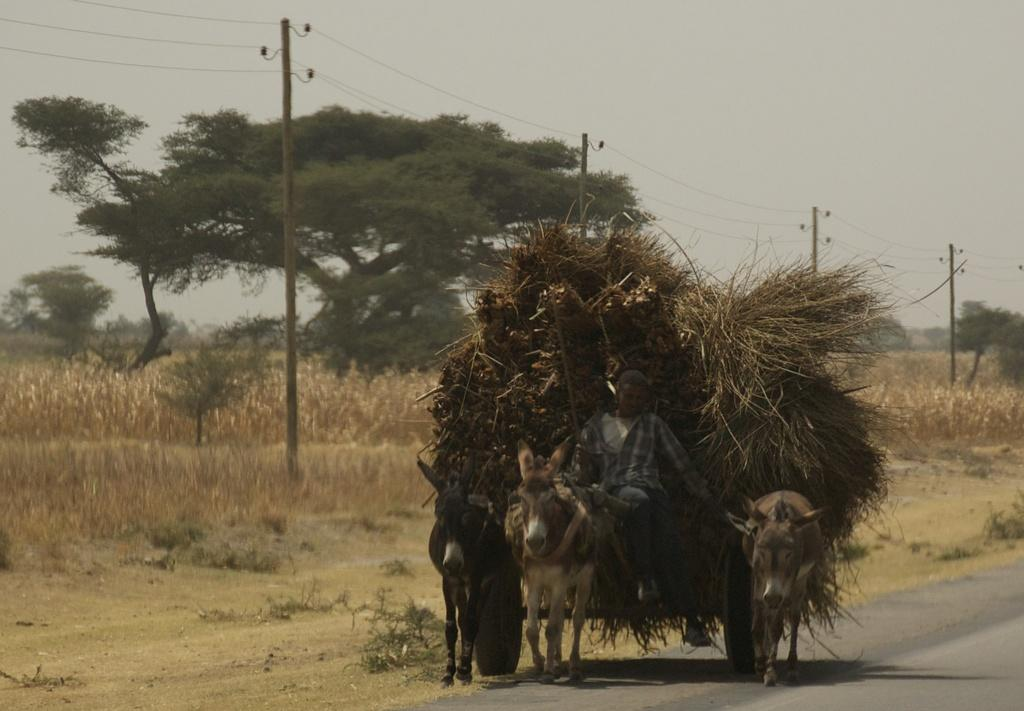What is on the cart in the image? There is grass on the cart. Who or what is sitting on the cart? A person is sitting on the cart. How many donkeys are in the image? There are three donkeys in the image. What can be seen in the image that is related to electricity? There are electric poles and wires in the image. What type of vegetation is present in the image? There are plants and trees in the image. What is visible in the background of the image? The sky is visible in the image. Can you hear the sound of the ocean in the image? There is no reference to an ocean or any sounds in the image, so it's not possible to determine if the sound of the ocean can be heard. 